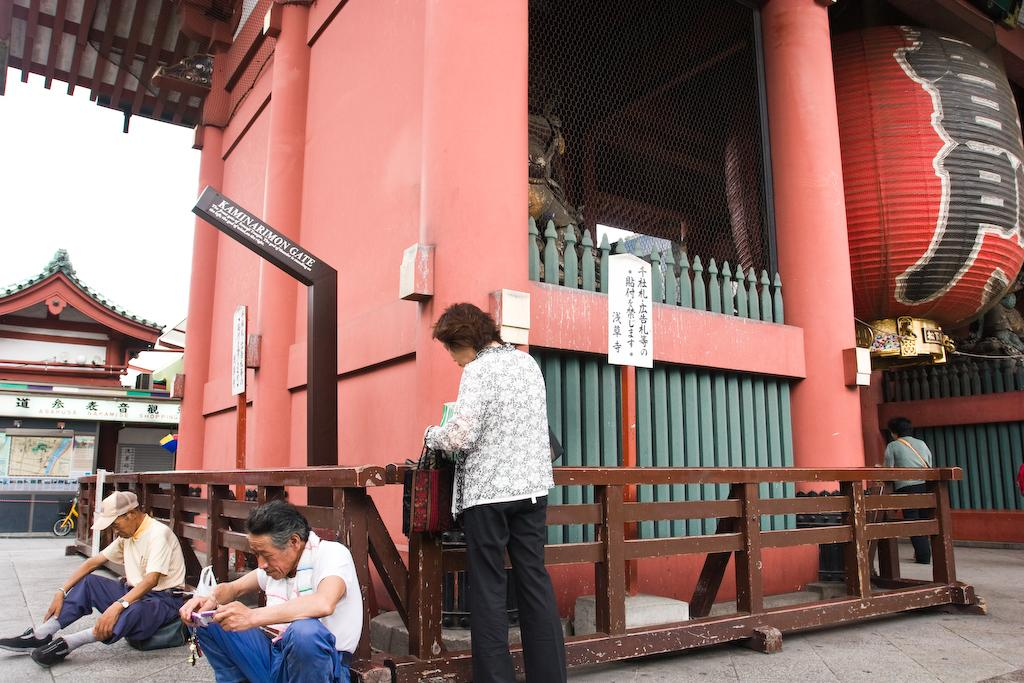What type of structures can be seen in the image? There are buildings in the image. What are the people in the image doing? There is a couple sitting and a human standing in the image. What is written or displayed on a surface in the image? There is a board with text in the image. How would you describe the weather based on the image? The sky is cloudy in the image. What type of badge is the person wearing in the image? There is no badge visible on any person in the image. What kind of bait is being used by the couple in the image? There is no fishing or bait-related activity depicted in the image; it features a couple sitting and a human standing. 